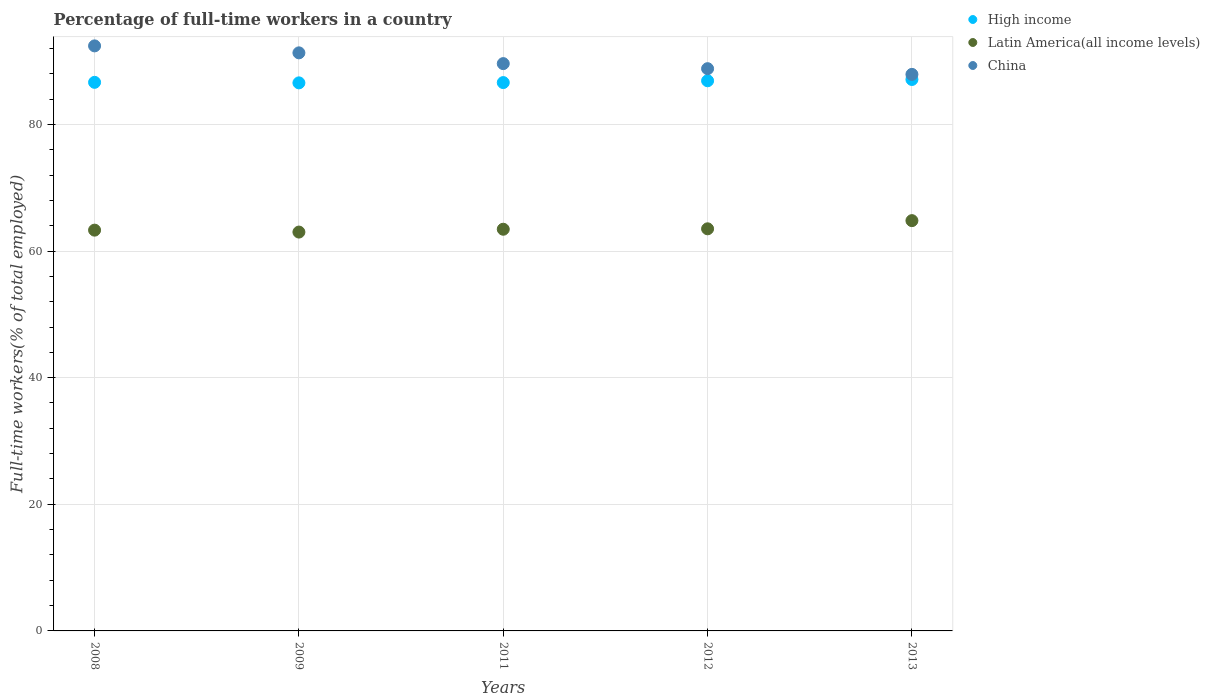How many different coloured dotlines are there?
Ensure brevity in your answer.  3. What is the percentage of full-time workers in High income in 2013?
Your response must be concise. 87.09. Across all years, what is the maximum percentage of full-time workers in China?
Ensure brevity in your answer.  92.4. Across all years, what is the minimum percentage of full-time workers in High income?
Make the answer very short. 86.56. In which year was the percentage of full-time workers in China maximum?
Your response must be concise. 2008. What is the total percentage of full-time workers in High income in the graph?
Offer a terse response. 433.79. What is the difference between the percentage of full-time workers in Latin America(all income levels) in 2009 and that in 2012?
Your answer should be compact. -0.51. What is the difference between the percentage of full-time workers in Latin America(all income levels) in 2013 and the percentage of full-time workers in High income in 2008?
Your answer should be very brief. -21.84. What is the average percentage of full-time workers in Latin America(all income levels) per year?
Your answer should be compact. 63.61. In the year 2012, what is the difference between the percentage of full-time workers in Latin America(all income levels) and percentage of full-time workers in China?
Ensure brevity in your answer.  -25.29. What is the ratio of the percentage of full-time workers in High income in 2008 to that in 2012?
Your response must be concise. 1. Is the percentage of full-time workers in Latin America(all income levels) in 2008 less than that in 2011?
Give a very brief answer. Yes. Is the difference between the percentage of full-time workers in Latin America(all income levels) in 2011 and 2012 greater than the difference between the percentage of full-time workers in China in 2011 and 2012?
Provide a succinct answer. No. What is the difference between the highest and the second highest percentage of full-time workers in High income?
Offer a very short reply. 0.2. What is the difference between the highest and the lowest percentage of full-time workers in Latin America(all income levels)?
Ensure brevity in your answer.  1.81. Is the sum of the percentage of full-time workers in Latin America(all income levels) in 2008 and 2013 greater than the maximum percentage of full-time workers in High income across all years?
Your answer should be compact. Yes. Is it the case that in every year, the sum of the percentage of full-time workers in China and percentage of full-time workers in High income  is greater than the percentage of full-time workers in Latin America(all income levels)?
Make the answer very short. Yes. How many dotlines are there?
Your answer should be compact. 3. How many years are there in the graph?
Provide a succinct answer. 5. Does the graph contain grids?
Keep it short and to the point. Yes. How many legend labels are there?
Your answer should be very brief. 3. How are the legend labels stacked?
Your answer should be very brief. Vertical. What is the title of the graph?
Your answer should be very brief. Percentage of full-time workers in a country. What is the label or title of the Y-axis?
Your answer should be compact. Full-time workers(% of total employed). What is the Full-time workers(% of total employed) of High income in 2008?
Make the answer very short. 86.64. What is the Full-time workers(% of total employed) in Latin America(all income levels) in 2008?
Your answer should be very brief. 63.3. What is the Full-time workers(% of total employed) in China in 2008?
Offer a very short reply. 92.4. What is the Full-time workers(% of total employed) in High income in 2009?
Ensure brevity in your answer.  86.56. What is the Full-time workers(% of total employed) of Latin America(all income levels) in 2009?
Your response must be concise. 62.99. What is the Full-time workers(% of total employed) in China in 2009?
Keep it short and to the point. 91.3. What is the Full-time workers(% of total employed) in High income in 2011?
Make the answer very short. 86.61. What is the Full-time workers(% of total employed) of Latin America(all income levels) in 2011?
Provide a succinct answer. 63.44. What is the Full-time workers(% of total employed) in China in 2011?
Your answer should be compact. 89.6. What is the Full-time workers(% of total employed) in High income in 2012?
Keep it short and to the point. 86.89. What is the Full-time workers(% of total employed) in Latin America(all income levels) in 2012?
Ensure brevity in your answer.  63.51. What is the Full-time workers(% of total employed) in China in 2012?
Provide a short and direct response. 88.8. What is the Full-time workers(% of total employed) in High income in 2013?
Offer a terse response. 87.09. What is the Full-time workers(% of total employed) of Latin America(all income levels) in 2013?
Your answer should be very brief. 64.8. What is the Full-time workers(% of total employed) of China in 2013?
Your answer should be compact. 87.9. Across all years, what is the maximum Full-time workers(% of total employed) of High income?
Provide a short and direct response. 87.09. Across all years, what is the maximum Full-time workers(% of total employed) in Latin America(all income levels)?
Make the answer very short. 64.8. Across all years, what is the maximum Full-time workers(% of total employed) in China?
Provide a short and direct response. 92.4. Across all years, what is the minimum Full-time workers(% of total employed) of High income?
Provide a succinct answer. 86.56. Across all years, what is the minimum Full-time workers(% of total employed) of Latin America(all income levels)?
Provide a succinct answer. 62.99. Across all years, what is the minimum Full-time workers(% of total employed) in China?
Your response must be concise. 87.9. What is the total Full-time workers(% of total employed) in High income in the graph?
Make the answer very short. 433.79. What is the total Full-time workers(% of total employed) in Latin America(all income levels) in the graph?
Provide a succinct answer. 318.04. What is the total Full-time workers(% of total employed) in China in the graph?
Give a very brief answer. 450. What is the difference between the Full-time workers(% of total employed) in High income in 2008 and that in 2009?
Keep it short and to the point. 0.08. What is the difference between the Full-time workers(% of total employed) in Latin America(all income levels) in 2008 and that in 2009?
Your answer should be compact. 0.3. What is the difference between the Full-time workers(% of total employed) of High income in 2008 and that in 2011?
Your answer should be very brief. 0.04. What is the difference between the Full-time workers(% of total employed) of Latin America(all income levels) in 2008 and that in 2011?
Offer a terse response. -0.14. What is the difference between the Full-time workers(% of total employed) in High income in 2008 and that in 2012?
Provide a succinct answer. -0.25. What is the difference between the Full-time workers(% of total employed) in Latin America(all income levels) in 2008 and that in 2012?
Your answer should be compact. -0.21. What is the difference between the Full-time workers(% of total employed) in China in 2008 and that in 2012?
Ensure brevity in your answer.  3.6. What is the difference between the Full-time workers(% of total employed) of High income in 2008 and that in 2013?
Provide a succinct answer. -0.45. What is the difference between the Full-time workers(% of total employed) of Latin America(all income levels) in 2008 and that in 2013?
Keep it short and to the point. -1.5. What is the difference between the Full-time workers(% of total employed) in High income in 2009 and that in 2011?
Your answer should be compact. -0.05. What is the difference between the Full-time workers(% of total employed) in Latin America(all income levels) in 2009 and that in 2011?
Ensure brevity in your answer.  -0.45. What is the difference between the Full-time workers(% of total employed) in High income in 2009 and that in 2012?
Offer a very short reply. -0.33. What is the difference between the Full-time workers(% of total employed) of Latin America(all income levels) in 2009 and that in 2012?
Provide a short and direct response. -0.52. What is the difference between the Full-time workers(% of total employed) of China in 2009 and that in 2012?
Ensure brevity in your answer.  2.5. What is the difference between the Full-time workers(% of total employed) in High income in 2009 and that in 2013?
Your answer should be compact. -0.53. What is the difference between the Full-time workers(% of total employed) in Latin America(all income levels) in 2009 and that in 2013?
Your answer should be very brief. -1.81. What is the difference between the Full-time workers(% of total employed) in China in 2009 and that in 2013?
Your answer should be very brief. 3.4. What is the difference between the Full-time workers(% of total employed) of High income in 2011 and that in 2012?
Your response must be concise. -0.29. What is the difference between the Full-time workers(% of total employed) of Latin America(all income levels) in 2011 and that in 2012?
Keep it short and to the point. -0.07. What is the difference between the Full-time workers(% of total employed) of High income in 2011 and that in 2013?
Make the answer very short. -0.49. What is the difference between the Full-time workers(% of total employed) of Latin America(all income levels) in 2011 and that in 2013?
Offer a terse response. -1.36. What is the difference between the Full-time workers(% of total employed) in China in 2011 and that in 2013?
Provide a succinct answer. 1.7. What is the difference between the Full-time workers(% of total employed) in High income in 2012 and that in 2013?
Keep it short and to the point. -0.2. What is the difference between the Full-time workers(% of total employed) of Latin America(all income levels) in 2012 and that in 2013?
Offer a terse response. -1.29. What is the difference between the Full-time workers(% of total employed) in High income in 2008 and the Full-time workers(% of total employed) in Latin America(all income levels) in 2009?
Ensure brevity in your answer.  23.65. What is the difference between the Full-time workers(% of total employed) of High income in 2008 and the Full-time workers(% of total employed) of China in 2009?
Offer a very short reply. -4.66. What is the difference between the Full-time workers(% of total employed) in Latin America(all income levels) in 2008 and the Full-time workers(% of total employed) in China in 2009?
Offer a very short reply. -28. What is the difference between the Full-time workers(% of total employed) of High income in 2008 and the Full-time workers(% of total employed) of Latin America(all income levels) in 2011?
Ensure brevity in your answer.  23.2. What is the difference between the Full-time workers(% of total employed) in High income in 2008 and the Full-time workers(% of total employed) in China in 2011?
Offer a very short reply. -2.96. What is the difference between the Full-time workers(% of total employed) of Latin America(all income levels) in 2008 and the Full-time workers(% of total employed) of China in 2011?
Ensure brevity in your answer.  -26.3. What is the difference between the Full-time workers(% of total employed) in High income in 2008 and the Full-time workers(% of total employed) in Latin America(all income levels) in 2012?
Offer a terse response. 23.13. What is the difference between the Full-time workers(% of total employed) in High income in 2008 and the Full-time workers(% of total employed) in China in 2012?
Make the answer very short. -2.16. What is the difference between the Full-time workers(% of total employed) of Latin America(all income levels) in 2008 and the Full-time workers(% of total employed) of China in 2012?
Give a very brief answer. -25.5. What is the difference between the Full-time workers(% of total employed) in High income in 2008 and the Full-time workers(% of total employed) in Latin America(all income levels) in 2013?
Keep it short and to the point. 21.84. What is the difference between the Full-time workers(% of total employed) of High income in 2008 and the Full-time workers(% of total employed) of China in 2013?
Offer a very short reply. -1.26. What is the difference between the Full-time workers(% of total employed) of Latin America(all income levels) in 2008 and the Full-time workers(% of total employed) of China in 2013?
Offer a very short reply. -24.6. What is the difference between the Full-time workers(% of total employed) of High income in 2009 and the Full-time workers(% of total employed) of Latin America(all income levels) in 2011?
Ensure brevity in your answer.  23.12. What is the difference between the Full-time workers(% of total employed) of High income in 2009 and the Full-time workers(% of total employed) of China in 2011?
Give a very brief answer. -3.04. What is the difference between the Full-time workers(% of total employed) in Latin America(all income levels) in 2009 and the Full-time workers(% of total employed) in China in 2011?
Make the answer very short. -26.61. What is the difference between the Full-time workers(% of total employed) in High income in 2009 and the Full-time workers(% of total employed) in Latin America(all income levels) in 2012?
Offer a very short reply. 23.05. What is the difference between the Full-time workers(% of total employed) in High income in 2009 and the Full-time workers(% of total employed) in China in 2012?
Make the answer very short. -2.24. What is the difference between the Full-time workers(% of total employed) of Latin America(all income levels) in 2009 and the Full-time workers(% of total employed) of China in 2012?
Your answer should be compact. -25.81. What is the difference between the Full-time workers(% of total employed) of High income in 2009 and the Full-time workers(% of total employed) of Latin America(all income levels) in 2013?
Keep it short and to the point. 21.76. What is the difference between the Full-time workers(% of total employed) in High income in 2009 and the Full-time workers(% of total employed) in China in 2013?
Your answer should be very brief. -1.34. What is the difference between the Full-time workers(% of total employed) of Latin America(all income levels) in 2009 and the Full-time workers(% of total employed) of China in 2013?
Provide a succinct answer. -24.91. What is the difference between the Full-time workers(% of total employed) of High income in 2011 and the Full-time workers(% of total employed) of Latin America(all income levels) in 2012?
Your answer should be compact. 23.1. What is the difference between the Full-time workers(% of total employed) of High income in 2011 and the Full-time workers(% of total employed) of China in 2012?
Your answer should be very brief. -2.19. What is the difference between the Full-time workers(% of total employed) of Latin America(all income levels) in 2011 and the Full-time workers(% of total employed) of China in 2012?
Your response must be concise. -25.36. What is the difference between the Full-time workers(% of total employed) in High income in 2011 and the Full-time workers(% of total employed) in Latin America(all income levels) in 2013?
Give a very brief answer. 21.81. What is the difference between the Full-time workers(% of total employed) in High income in 2011 and the Full-time workers(% of total employed) in China in 2013?
Your response must be concise. -1.29. What is the difference between the Full-time workers(% of total employed) of Latin America(all income levels) in 2011 and the Full-time workers(% of total employed) of China in 2013?
Provide a succinct answer. -24.46. What is the difference between the Full-time workers(% of total employed) of High income in 2012 and the Full-time workers(% of total employed) of Latin America(all income levels) in 2013?
Your answer should be very brief. 22.09. What is the difference between the Full-time workers(% of total employed) of High income in 2012 and the Full-time workers(% of total employed) of China in 2013?
Offer a very short reply. -1.01. What is the difference between the Full-time workers(% of total employed) in Latin America(all income levels) in 2012 and the Full-time workers(% of total employed) in China in 2013?
Your answer should be very brief. -24.39. What is the average Full-time workers(% of total employed) in High income per year?
Give a very brief answer. 86.76. What is the average Full-time workers(% of total employed) in Latin America(all income levels) per year?
Ensure brevity in your answer.  63.61. What is the average Full-time workers(% of total employed) in China per year?
Offer a terse response. 90. In the year 2008, what is the difference between the Full-time workers(% of total employed) of High income and Full-time workers(% of total employed) of Latin America(all income levels)?
Keep it short and to the point. 23.34. In the year 2008, what is the difference between the Full-time workers(% of total employed) of High income and Full-time workers(% of total employed) of China?
Your response must be concise. -5.76. In the year 2008, what is the difference between the Full-time workers(% of total employed) in Latin America(all income levels) and Full-time workers(% of total employed) in China?
Your response must be concise. -29.1. In the year 2009, what is the difference between the Full-time workers(% of total employed) in High income and Full-time workers(% of total employed) in Latin America(all income levels)?
Your answer should be compact. 23.56. In the year 2009, what is the difference between the Full-time workers(% of total employed) in High income and Full-time workers(% of total employed) in China?
Offer a terse response. -4.74. In the year 2009, what is the difference between the Full-time workers(% of total employed) in Latin America(all income levels) and Full-time workers(% of total employed) in China?
Your answer should be compact. -28.31. In the year 2011, what is the difference between the Full-time workers(% of total employed) in High income and Full-time workers(% of total employed) in Latin America(all income levels)?
Ensure brevity in your answer.  23.16. In the year 2011, what is the difference between the Full-time workers(% of total employed) in High income and Full-time workers(% of total employed) in China?
Make the answer very short. -3. In the year 2011, what is the difference between the Full-time workers(% of total employed) of Latin America(all income levels) and Full-time workers(% of total employed) of China?
Ensure brevity in your answer.  -26.16. In the year 2012, what is the difference between the Full-time workers(% of total employed) of High income and Full-time workers(% of total employed) of Latin America(all income levels)?
Provide a short and direct response. 23.38. In the year 2012, what is the difference between the Full-time workers(% of total employed) in High income and Full-time workers(% of total employed) in China?
Ensure brevity in your answer.  -1.91. In the year 2012, what is the difference between the Full-time workers(% of total employed) in Latin America(all income levels) and Full-time workers(% of total employed) in China?
Make the answer very short. -25.29. In the year 2013, what is the difference between the Full-time workers(% of total employed) in High income and Full-time workers(% of total employed) in Latin America(all income levels)?
Your answer should be very brief. 22.29. In the year 2013, what is the difference between the Full-time workers(% of total employed) in High income and Full-time workers(% of total employed) in China?
Your answer should be compact. -0.81. In the year 2013, what is the difference between the Full-time workers(% of total employed) in Latin America(all income levels) and Full-time workers(% of total employed) in China?
Your answer should be very brief. -23.1. What is the ratio of the Full-time workers(% of total employed) in High income in 2008 to that in 2009?
Your answer should be very brief. 1. What is the ratio of the Full-time workers(% of total employed) in China in 2008 to that in 2011?
Provide a succinct answer. 1.03. What is the ratio of the Full-time workers(% of total employed) of High income in 2008 to that in 2012?
Provide a short and direct response. 1. What is the ratio of the Full-time workers(% of total employed) in China in 2008 to that in 2012?
Provide a short and direct response. 1.04. What is the ratio of the Full-time workers(% of total employed) in Latin America(all income levels) in 2008 to that in 2013?
Your answer should be very brief. 0.98. What is the ratio of the Full-time workers(% of total employed) in China in 2008 to that in 2013?
Offer a terse response. 1.05. What is the ratio of the Full-time workers(% of total employed) in Latin America(all income levels) in 2009 to that in 2011?
Your answer should be very brief. 0.99. What is the ratio of the Full-time workers(% of total employed) of China in 2009 to that in 2011?
Give a very brief answer. 1.02. What is the ratio of the Full-time workers(% of total employed) in High income in 2009 to that in 2012?
Give a very brief answer. 1. What is the ratio of the Full-time workers(% of total employed) of Latin America(all income levels) in 2009 to that in 2012?
Keep it short and to the point. 0.99. What is the ratio of the Full-time workers(% of total employed) in China in 2009 to that in 2012?
Make the answer very short. 1.03. What is the ratio of the Full-time workers(% of total employed) in High income in 2009 to that in 2013?
Keep it short and to the point. 0.99. What is the ratio of the Full-time workers(% of total employed) of Latin America(all income levels) in 2009 to that in 2013?
Offer a very short reply. 0.97. What is the ratio of the Full-time workers(% of total employed) in China in 2009 to that in 2013?
Your answer should be very brief. 1.04. What is the ratio of the Full-time workers(% of total employed) of High income in 2011 to that in 2012?
Your answer should be compact. 1. What is the ratio of the Full-time workers(% of total employed) of High income in 2011 to that in 2013?
Provide a succinct answer. 0.99. What is the ratio of the Full-time workers(% of total employed) in Latin America(all income levels) in 2011 to that in 2013?
Your response must be concise. 0.98. What is the ratio of the Full-time workers(% of total employed) of China in 2011 to that in 2013?
Provide a short and direct response. 1.02. What is the ratio of the Full-time workers(% of total employed) of High income in 2012 to that in 2013?
Provide a succinct answer. 1. What is the ratio of the Full-time workers(% of total employed) of Latin America(all income levels) in 2012 to that in 2013?
Provide a short and direct response. 0.98. What is the ratio of the Full-time workers(% of total employed) of China in 2012 to that in 2013?
Make the answer very short. 1.01. What is the difference between the highest and the second highest Full-time workers(% of total employed) in High income?
Make the answer very short. 0.2. What is the difference between the highest and the second highest Full-time workers(% of total employed) of Latin America(all income levels)?
Your answer should be very brief. 1.29. What is the difference between the highest and the second highest Full-time workers(% of total employed) in China?
Your answer should be very brief. 1.1. What is the difference between the highest and the lowest Full-time workers(% of total employed) of High income?
Make the answer very short. 0.53. What is the difference between the highest and the lowest Full-time workers(% of total employed) of Latin America(all income levels)?
Your response must be concise. 1.81. 